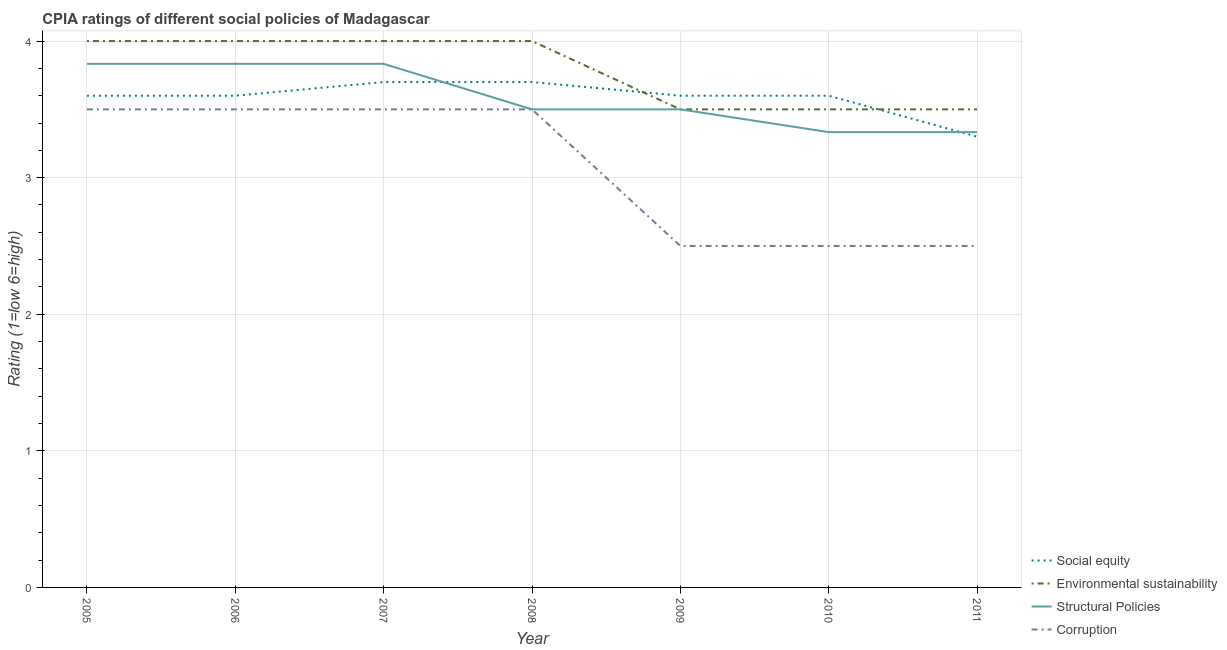How many different coloured lines are there?
Keep it short and to the point. 4. What is the cpia rating of environmental sustainability in 2008?
Ensure brevity in your answer.  4. In which year was the cpia rating of environmental sustainability maximum?
Your answer should be compact. 2005. What is the difference between the cpia rating of social equity in 2005 and that in 2006?
Give a very brief answer. 0. What is the difference between the cpia rating of social equity in 2005 and the cpia rating of corruption in 2008?
Your answer should be very brief. 0.1. What is the average cpia rating of social equity per year?
Provide a short and direct response. 3.59. In the year 2008, what is the difference between the cpia rating of environmental sustainability and cpia rating of social equity?
Offer a terse response. 0.3. In how many years, is the cpia rating of structural policies greater than 1.6?
Make the answer very short. 7. What is the ratio of the cpia rating of structural policies in 2006 to that in 2009?
Make the answer very short. 1.1. What is the difference between the highest and the lowest cpia rating of corruption?
Make the answer very short. 1. In how many years, is the cpia rating of social equity greater than the average cpia rating of social equity taken over all years?
Make the answer very short. 6. Is the sum of the cpia rating of structural policies in 2005 and 2011 greater than the maximum cpia rating of corruption across all years?
Your response must be concise. Yes. Is it the case that in every year, the sum of the cpia rating of corruption and cpia rating of environmental sustainability is greater than the sum of cpia rating of structural policies and cpia rating of social equity?
Make the answer very short. No. Is it the case that in every year, the sum of the cpia rating of social equity and cpia rating of environmental sustainability is greater than the cpia rating of structural policies?
Offer a very short reply. Yes. What is the difference between two consecutive major ticks on the Y-axis?
Your answer should be very brief. 1. How are the legend labels stacked?
Ensure brevity in your answer.  Vertical. What is the title of the graph?
Offer a very short reply. CPIA ratings of different social policies of Madagascar. What is the label or title of the X-axis?
Offer a very short reply. Year. What is the Rating (1=low 6=high) in Environmental sustainability in 2005?
Ensure brevity in your answer.  4. What is the Rating (1=low 6=high) of Structural Policies in 2005?
Offer a very short reply. 3.83. What is the Rating (1=low 6=high) of Corruption in 2005?
Provide a short and direct response. 3.5. What is the Rating (1=low 6=high) in Social equity in 2006?
Your answer should be very brief. 3.6. What is the Rating (1=low 6=high) in Environmental sustainability in 2006?
Provide a short and direct response. 4. What is the Rating (1=low 6=high) of Structural Policies in 2006?
Offer a terse response. 3.83. What is the Rating (1=low 6=high) of Corruption in 2006?
Give a very brief answer. 3.5. What is the Rating (1=low 6=high) of Social equity in 2007?
Your answer should be compact. 3.7. What is the Rating (1=low 6=high) of Environmental sustainability in 2007?
Your answer should be very brief. 4. What is the Rating (1=low 6=high) of Structural Policies in 2007?
Give a very brief answer. 3.83. What is the Rating (1=low 6=high) in Corruption in 2007?
Your answer should be very brief. 3.5. What is the Rating (1=low 6=high) of Social equity in 2008?
Provide a succinct answer. 3.7. What is the Rating (1=low 6=high) of Environmental sustainability in 2008?
Your answer should be compact. 4. What is the Rating (1=low 6=high) of Corruption in 2008?
Give a very brief answer. 3.5. What is the Rating (1=low 6=high) of Environmental sustainability in 2009?
Keep it short and to the point. 3.5. What is the Rating (1=low 6=high) in Structural Policies in 2010?
Ensure brevity in your answer.  3.33. What is the Rating (1=low 6=high) of Corruption in 2010?
Offer a terse response. 2.5. What is the Rating (1=low 6=high) in Structural Policies in 2011?
Give a very brief answer. 3.33. What is the Rating (1=low 6=high) in Corruption in 2011?
Your answer should be compact. 2.5. Across all years, what is the maximum Rating (1=low 6=high) in Social equity?
Ensure brevity in your answer.  3.7. Across all years, what is the maximum Rating (1=low 6=high) of Structural Policies?
Your answer should be compact. 3.83. Across all years, what is the maximum Rating (1=low 6=high) of Corruption?
Make the answer very short. 3.5. Across all years, what is the minimum Rating (1=low 6=high) of Social equity?
Offer a very short reply. 3.3. Across all years, what is the minimum Rating (1=low 6=high) in Environmental sustainability?
Keep it short and to the point. 3.5. Across all years, what is the minimum Rating (1=low 6=high) of Structural Policies?
Provide a short and direct response. 3.33. Across all years, what is the minimum Rating (1=low 6=high) of Corruption?
Give a very brief answer. 2.5. What is the total Rating (1=low 6=high) of Social equity in the graph?
Ensure brevity in your answer.  25.1. What is the total Rating (1=low 6=high) in Structural Policies in the graph?
Offer a very short reply. 25.17. What is the difference between the Rating (1=low 6=high) of Structural Policies in 2005 and that in 2006?
Provide a short and direct response. 0. What is the difference between the Rating (1=low 6=high) in Corruption in 2005 and that in 2006?
Offer a very short reply. 0. What is the difference between the Rating (1=low 6=high) of Social equity in 2005 and that in 2007?
Offer a terse response. -0.1. What is the difference between the Rating (1=low 6=high) of Corruption in 2005 and that in 2007?
Give a very brief answer. 0. What is the difference between the Rating (1=low 6=high) in Social equity in 2005 and that in 2008?
Give a very brief answer. -0.1. What is the difference between the Rating (1=low 6=high) in Environmental sustainability in 2005 and that in 2008?
Ensure brevity in your answer.  0. What is the difference between the Rating (1=low 6=high) of Structural Policies in 2005 and that in 2008?
Give a very brief answer. 0.33. What is the difference between the Rating (1=low 6=high) in Social equity in 2005 and that in 2009?
Your answer should be compact. 0. What is the difference between the Rating (1=low 6=high) of Structural Policies in 2005 and that in 2009?
Offer a terse response. 0.33. What is the difference between the Rating (1=low 6=high) of Social equity in 2005 and that in 2010?
Ensure brevity in your answer.  0. What is the difference between the Rating (1=low 6=high) of Environmental sustainability in 2005 and that in 2010?
Your answer should be compact. 0.5. What is the difference between the Rating (1=low 6=high) of Structural Policies in 2005 and that in 2010?
Offer a terse response. 0.5. What is the difference between the Rating (1=low 6=high) in Corruption in 2005 and that in 2010?
Your response must be concise. 1. What is the difference between the Rating (1=low 6=high) in Environmental sustainability in 2005 and that in 2011?
Your response must be concise. 0.5. What is the difference between the Rating (1=low 6=high) in Social equity in 2006 and that in 2007?
Your response must be concise. -0.1. What is the difference between the Rating (1=low 6=high) in Environmental sustainability in 2006 and that in 2007?
Your answer should be very brief. 0. What is the difference between the Rating (1=low 6=high) of Structural Policies in 2006 and that in 2007?
Keep it short and to the point. 0. What is the difference between the Rating (1=low 6=high) of Corruption in 2006 and that in 2007?
Provide a succinct answer. 0. What is the difference between the Rating (1=low 6=high) of Corruption in 2006 and that in 2008?
Ensure brevity in your answer.  0. What is the difference between the Rating (1=low 6=high) of Environmental sustainability in 2006 and that in 2009?
Make the answer very short. 0.5. What is the difference between the Rating (1=low 6=high) in Structural Policies in 2006 and that in 2009?
Give a very brief answer. 0.33. What is the difference between the Rating (1=low 6=high) of Social equity in 2006 and that in 2010?
Provide a succinct answer. 0. What is the difference between the Rating (1=low 6=high) in Social equity in 2006 and that in 2011?
Make the answer very short. 0.3. What is the difference between the Rating (1=low 6=high) in Environmental sustainability in 2006 and that in 2011?
Offer a terse response. 0.5. What is the difference between the Rating (1=low 6=high) in Corruption in 2006 and that in 2011?
Offer a terse response. 1. What is the difference between the Rating (1=low 6=high) of Social equity in 2007 and that in 2008?
Make the answer very short. 0. What is the difference between the Rating (1=low 6=high) in Corruption in 2007 and that in 2008?
Offer a very short reply. 0. What is the difference between the Rating (1=low 6=high) in Environmental sustainability in 2007 and that in 2010?
Offer a very short reply. 0.5. What is the difference between the Rating (1=low 6=high) in Social equity in 2007 and that in 2011?
Make the answer very short. 0.4. What is the difference between the Rating (1=low 6=high) in Structural Policies in 2008 and that in 2009?
Ensure brevity in your answer.  0. What is the difference between the Rating (1=low 6=high) in Environmental sustainability in 2008 and that in 2010?
Ensure brevity in your answer.  0.5. What is the difference between the Rating (1=low 6=high) of Corruption in 2008 and that in 2010?
Offer a terse response. 1. What is the difference between the Rating (1=low 6=high) of Structural Policies in 2008 and that in 2011?
Make the answer very short. 0.17. What is the difference between the Rating (1=low 6=high) in Corruption in 2008 and that in 2011?
Give a very brief answer. 1. What is the difference between the Rating (1=low 6=high) in Social equity in 2009 and that in 2010?
Give a very brief answer. 0. What is the difference between the Rating (1=low 6=high) in Environmental sustainability in 2009 and that in 2010?
Provide a succinct answer. 0. What is the difference between the Rating (1=low 6=high) in Structural Policies in 2009 and that in 2010?
Provide a short and direct response. 0.17. What is the difference between the Rating (1=low 6=high) of Corruption in 2009 and that in 2010?
Ensure brevity in your answer.  0. What is the difference between the Rating (1=low 6=high) in Social equity in 2009 and that in 2011?
Make the answer very short. 0.3. What is the difference between the Rating (1=low 6=high) in Structural Policies in 2010 and that in 2011?
Your response must be concise. 0. What is the difference between the Rating (1=low 6=high) in Social equity in 2005 and the Rating (1=low 6=high) in Environmental sustainability in 2006?
Offer a very short reply. -0.4. What is the difference between the Rating (1=low 6=high) in Social equity in 2005 and the Rating (1=low 6=high) in Structural Policies in 2006?
Keep it short and to the point. -0.23. What is the difference between the Rating (1=low 6=high) in Environmental sustainability in 2005 and the Rating (1=low 6=high) in Structural Policies in 2006?
Offer a very short reply. 0.17. What is the difference between the Rating (1=low 6=high) in Structural Policies in 2005 and the Rating (1=low 6=high) in Corruption in 2006?
Offer a very short reply. 0.33. What is the difference between the Rating (1=low 6=high) in Social equity in 2005 and the Rating (1=low 6=high) in Environmental sustainability in 2007?
Provide a succinct answer. -0.4. What is the difference between the Rating (1=low 6=high) in Social equity in 2005 and the Rating (1=low 6=high) in Structural Policies in 2007?
Give a very brief answer. -0.23. What is the difference between the Rating (1=low 6=high) of Social equity in 2005 and the Rating (1=low 6=high) of Corruption in 2007?
Ensure brevity in your answer.  0.1. What is the difference between the Rating (1=low 6=high) in Environmental sustainability in 2005 and the Rating (1=low 6=high) in Corruption in 2007?
Ensure brevity in your answer.  0.5. What is the difference between the Rating (1=low 6=high) of Social equity in 2005 and the Rating (1=low 6=high) of Environmental sustainability in 2008?
Keep it short and to the point. -0.4. What is the difference between the Rating (1=low 6=high) of Social equity in 2005 and the Rating (1=low 6=high) of Corruption in 2008?
Your response must be concise. 0.1. What is the difference between the Rating (1=low 6=high) in Environmental sustainability in 2005 and the Rating (1=low 6=high) in Corruption in 2008?
Your answer should be very brief. 0.5. What is the difference between the Rating (1=low 6=high) of Structural Policies in 2005 and the Rating (1=low 6=high) of Corruption in 2008?
Your answer should be very brief. 0.33. What is the difference between the Rating (1=low 6=high) in Social equity in 2005 and the Rating (1=low 6=high) in Environmental sustainability in 2009?
Provide a short and direct response. 0.1. What is the difference between the Rating (1=low 6=high) in Social equity in 2005 and the Rating (1=low 6=high) in Corruption in 2009?
Provide a short and direct response. 1.1. What is the difference between the Rating (1=low 6=high) of Environmental sustainability in 2005 and the Rating (1=low 6=high) of Structural Policies in 2009?
Provide a succinct answer. 0.5. What is the difference between the Rating (1=low 6=high) of Environmental sustainability in 2005 and the Rating (1=low 6=high) of Corruption in 2009?
Your response must be concise. 1.5. What is the difference between the Rating (1=low 6=high) in Structural Policies in 2005 and the Rating (1=low 6=high) in Corruption in 2009?
Your response must be concise. 1.33. What is the difference between the Rating (1=low 6=high) of Social equity in 2005 and the Rating (1=low 6=high) of Environmental sustainability in 2010?
Provide a short and direct response. 0.1. What is the difference between the Rating (1=low 6=high) in Social equity in 2005 and the Rating (1=low 6=high) in Structural Policies in 2010?
Your answer should be very brief. 0.27. What is the difference between the Rating (1=low 6=high) in Social equity in 2005 and the Rating (1=low 6=high) in Corruption in 2010?
Provide a succinct answer. 1.1. What is the difference between the Rating (1=low 6=high) in Environmental sustainability in 2005 and the Rating (1=low 6=high) in Structural Policies in 2010?
Your answer should be compact. 0.67. What is the difference between the Rating (1=low 6=high) in Environmental sustainability in 2005 and the Rating (1=low 6=high) in Corruption in 2010?
Keep it short and to the point. 1.5. What is the difference between the Rating (1=low 6=high) of Social equity in 2005 and the Rating (1=low 6=high) of Structural Policies in 2011?
Offer a very short reply. 0.27. What is the difference between the Rating (1=low 6=high) of Environmental sustainability in 2005 and the Rating (1=low 6=high) of Corruption in 2011?
Keep it short and to the point. 1.5. What is the difference between the Rating (1=low 6=high) of Structural Policies in 2005 and the Rating (1=low 6=high) of Corruption in 2011?
Offer a terse response. 1.33. What is the difference between the Rating (1=low 6=high) in Social equity in 2006 and the Rating (1=low 6=high) in Structural Policies in 2007?
Give a very brief answer. -0.23. What is the difference between the Rating (1=low 6=high) of Social equity in 2006 and the Rating (1=low 6=high) of Corruption in 2007?
Ensure brevity in your answer.  0.1. What is the difference between the Rating (1=low 6=high) in Environmental sustainability in 2006 and the Rating (1=low 6=high) in Corruption in 2007?
Offer a terse response. 0.5. What is the difference between the Rating (1=low 6=high) in Social equity in 2006 and the Rating (1=low 6=high) in Environmental sustainability in 2008?
Provide a succinct answer. -0.4. What is the difference between the Rating (1=low 6=high) of Social equity in 2006 and the Rating (1=low 6=high) of Structural Policies in 2008?
Offer a terse response. 0.1. What is the difference between the Rating (1=low 6=high) in Social equity in 2006 and the Rating (1=low 6=high) in Corruption in 2008?
Offer a very short reply. 0.1. What is the difference between the Rating (1=low 6=high) of Environmental sustainability in 2006 and the Rating (1=low 6=high) of Structural Policies in 2008?
Provide a succinct answer. 0.5. What is the difference between the Rating (1=low 6=high) in Structural Policies in 2006 and the Rating (1=low 6=high) in Corruption in 2008?
Offer a very short reply. 0.33. What is the difference between the Rating (1=low 6=high) of Social equity in 2006 and the Rating (1=low 6=high) of Environmental sustainability in 2009?
Provide a short and direct response. 0.1. What is the difference between the Rating (1=low 6=high) of Social equity in 2006 and the Rating (1=low 6=high) of Structural Policies in 2009?
Provide a succinct answer. 0.1. What is the difference between the Rating (1=low 6=high) of Social equity in 2006 and the Rating (1=low 6=high) of Corruption in 2009?
Offer a very short reply. 1.1. What is the difference between the Rating (1=low 6=high) in Environmental sustainability in 2006 and the Rating (1=low 6=high) in Structural Policies in 2009?
Provide a short and direct response. 0.5. What is the difference between the Rating (1=low 6=high) in Environmental sustainability in 2006 and the Rating (1=low 6=high) in Corruption in 2009?
Your response must be concise. 1.5. What is the difference between the Rating (1=low 6=high) of Social equity in 2006 and the Rating (1=low 6=high) of Environmental sustainability in 2010?
Provide a short and direct response. 0.1. What is the difference between the Rating (1=low 6=high) of Social equity in 2006 and the Rating (1=low 6=high) of Structural Policies in 2010?
Offer a terse response. 0.27. What is the difference between the Rating (1=low 6=high) in Social equity in 2006 and the Rating (1=low 6=high) in Corruption in 2010?
Give a very brief answer. 1.1. What is the difference between the Rating (1=low 6=high) in Environmental sustainability in 2006 and the Rating (1=low 6=high) in Structural Policies in 2010?
Ensure brevity in your answer.  0.67. What is the difference between the Rating (1=low 6=high) in Environmental sustainability in 2006 and the Rating (1=low 6=high) in Corruption in 2010?
Offer a terse response. 1.5. What is the difference between the Rating (1=low 6=high) of Structural Policies in 2006 and the Rating (1=low 6=high) of Corruption in 2010?
Offer a very short reply. 1.33. What is the difference between the Rating (1=low 6=high) in Social equity in 2006 and the Rating (1=low 6=high) in Environmental sustainability in 2011?
Make the answer very short. 0.1. What is the difference between the Rating (1=low 6=high) of Social equity in 2006 and the Rating (1=low 6=high) of Structural Policies in 2011?
Your answer should be very brief. 0.27. What is the difference between the Rating (1=low 6=high) of Social equity in 2006 and the Rating (1=low 6=high) of Corruption in 2011?
Your answer should be very brief. 1.1. What is the difference between the Rating (1=low 6=high) of Structural Policies in 2006 and the Rating (1=low 6=high) of Corruption in 2011?
Ensure brevity in your answer.  1.33. What is the difference between the Rating (1=low 6=high) in Social equity in 2007 and the Rating (1=low 6=high) in Corruption in 2008?
Your response must be concise. 0.2. What is the difference between the Rating (1=low 6=high) in Environmental sustainability in 2007 and the Rating (1=low 6=high) in Structural Policies in 2008?
Your response must be concise. 0.5. What is the difference between the Rating (1=low 6=high) in Social equity in 2007 and the Rating (1=low 6=high) in Corruption in 2009?
Your answer should be very brief. 1.2. What is the difference between the Rating (1=low 6=high) in Environmental sustainability in 2007 and the Rating (1=low 6=high) in Structural Policies in 2009?
Your answer should be compact. 0.5. What is the difference between the Rating (1=low 6=high) of Structural Policies in 2007 and the Rating (1=low 6=high) of Corruption in 2009?
Ensure brevity in your answer.  1.33. What is the difference between the Rating (1=low 6=high) of Social equity in 2007 and the Rating (1=low 6=high) of Environmental sustainability in 2010?
Offer a terse response. 0.2. What is the difference between the Rating (1=low 6=high) in Social equity in 2007 and the Rating (1=low 6=high) in Structural Policies in 2010?
Make the answer very short. 0.37. What is the difference between the Rating (1=low 6=high) in Social equity in 2007 and the Rating (1=low 6=high) in Structural Policies in 2011?
Offer a terse response. 0.37. What is the difference between the Rating (1=low 6=high) of Environmental sustainability in 2007 and the Rating (1=low 6=high) of Corruption in 2011?
Provide a succinct answer. 1.5. What is the difference between the Rating (1=low 6=high) in Social equity in 2008 and the Rating (1=low 6=high) in Environmental sustainability in 2009?
Offer a terse response. 0.2. What is the difference between the Rating (1=low 6=high) in Social equity in 2008 and the Rating (1=low 6=high) in Structural Policies in 2009?
Ensure brevity in your answer.  0.2. What is the difference between the Rating (1=low 6=high) in Environmental sustainability in 2008 and the Rating (1=low 6=high) in Corruption in 2009?
Offer a very short reply. 1.5. What is the difference between the Rating (1=low 6=high) in Structural Policies in 2008 and the Rating (1=low 6=high) in Corruption in 2009?
Your response must be concise. 1. What is the difference between the Rating (1=low 6=high) in Social equity in 2008 and the Rating (1=low 6=high) in Structural Policies in 2010?
Provide a succinct answer. 0.37. What is the difference between the Rating (1=low 6=high) of Environmental sustainability in 2008 and the Rating (1=low 6=high) of Structural Policies in 2010?
Offer a very short reply. 0.67. What is the difference between the Rating (1=low 6=high) in Structural Policies in 2008 and the Rating (1=low 6=high) in Corruption in 2010?
Provide a short and direct response. 1. What is the difference between the Rating (1=low 6=high) in Social equity in 2008 and the Rating (1=low 6=high) in Environmental sustainability in 2011?
Your answer should be very brief. 0.2. What is the difference between the Rating (1=low 6=high) in Social equity in 2008 and the Rating (1=low 6=high) in Structural Policies in 2011?
Your answer should be compact. 0.37. What is the difference between the Rating (1=low 6=high) of Environmental sustainability in 2008 and the Rating (1=low 6=high) of Structural Policies in 2011?
Your answer should be compact. 0.67. What is the difference between the Rating (1=low 6=high) in Structural Policies in 2008 and the Rating (1=low 6=high) in Corruption in 2011?
Your answer should be compact. 1. What is the difference between the Rating (1=low 6=high) in Social equity in 2009 and the Rating (1=low 6=high) in Structural Policies in 2010?
Your answer should be compact. 0.27. What is the difference between the Rating (1=low 6=high) in Social equity in 2009 and the Rating (1=low 6=high) in Corruption in 2010?
Give a very brief answer. 1.1. What is the difference between the Rating (1=low 6=high) in Environmental sustainability in 2009 and the Rating (1=low 6=high) in Structural Policies in 2010?
Offer a terse response. 0.17. What is the difference between the Rating (1=low 6=high) in Social equity in 2009 and the Rating (1=low 6=high) in Structural Policies in 2011?
Your response must be concise. 0.27. What is the difference between the Rating (1=low 6=high) of Social equity in 2009 and the Rating (1=low 6=high) of Corruption in 2011?
Offer a very short reply. 1.1. What is the difference between the Rating (1=low 6=high) in Structural Policies in 2009 and the Rating (1=low 6=high) in Corruption in 2011?
Provide a succinct answer. 1. What is the difference between the Rating (1=low 6=high) of Social equity in 2010 and the Rating (1=low 6=high) of Environmental sustainability in 2011?
Your response must be concise. 0.1. What is the difference between the Rating (1=low 6=high) in Social equity in 2010 and the Rating (1=low 6=high) in Structural Policies in 2011?
Provide a short and direct response. 0.27. What is the difference between the Rating (1=low 6=high) of Environmental sustainability in 2010 and the Rating (1=low 6=high) of Structural Policies in 2011?
Provide a succinct answer. 0.17. What is the difference between the Rating (1=low 6=high) of Structural Policies in 2010 and the Rating (1=low 6=high) of Corruption in 2011?
Make the answer very short. 0.83. What is the average Rating (1=low 6=high) of Social equity per year?
Make the answer very short. 3.59. What is the average Rating (1=low 6=high) in Environmental sustainability per year?
Give a very brief answer. 3.79. What is the average Rating (1=low 6=high) in Structural Policies per year?
Provide a succinct answer. 3.6. What is the average Rating (1=low 6=high) of Corruption per year?
Offer a terse response. 3.07. In the year 2005, what is the difference between the Rating (1=low 6=high) of Social equity and Rating (1=low 6=high) of Environmental sustainability?
Offer a very short reply. -0.4. In the year 2005, what is the difference between the Rating (1=low 6=high) in Social equity and Rating (1=low 6=high) in Structural Policies?
Make the answer very short. -0.23. In the year 2005, what is the difference between the Rating (1=low 6=high) in Social equity and Rating (1=low 6=high) in Corruption?
Your answer should be compact. 0.1. In the year 2005, what is the difference between the Rating (1=low 6=high) in Environmental sustainability and Rating (1=low 6=high) in Structural Policies?
Provide a succinct answer. 0.17. In the year 2005, what is the difference between the Rating (1=low 6=high) of Environmental sustainability and Rating (1=low 6=high) of Corruption?
Your answer should be very brief. 0.5. In the year 2005, what is the difference between the Rating (1=low 6=high) of Structural Policies and Rating (1=low 6=high) of Corruption?
Provide a succinct answer. 0.33. In the year 2006, what is the difference between the Rating (1=low 6=high) in Social equity and Rating (1=low 6=high) in Structural Policies?
Keep it short and to the point. -0.23. In the year 2006, what is the difference between the Rating (1=low 6=high) in Environmental sustainability and Rating (1=low 6=high) in Structural Policies?
Ensure brevity in your answer.  0.17. In the year 2007, what is the difference between the Rating (1=low 6=high) in Social equity and Rating (1=low 6=high) in Environmental sustainability?
Provide a succinct answer. -0.3. In the year 2007, what is the difference between the Rating (1=low 6=high) of Social equity and Rating (1=low 6=high) of Structural Policies?
Provide a short and direct response. -0.13. In the year 2007, what is the difference between the Rating (1=low 6=high) of Structural Policies and Rating (1=low 6=high) of Corruption?
Make the answer very short. 0.33. In the year 2008, what is the difference between the Rating (1=low 6=high) of Environmental sustainability and Rating (1=low 6=high) of Structural Policies?
Offer a very short reply. 0.5. In the year 2009, what is the difference between the Rating (1=low 6=high) of Social equity and Rating (1=low 6=high) of Corruption?
Offer a very short reply. 1.1. In the year 2009, what is the difference between the Rating (1=low 6=high) of Environmental sustainability and Rating (1=low 6=high) of Structural Policies?
Provide a short and direct response. 0. In the year 2009, what is the difference between the Rating (1=low 6=high) of Environmental sustainability and Rating (1=low 6=high) of Corruption?
Provide a succinct answer. 1. In the year 2010, what is the difference between the Rating (1=low 6=high) of Social equity and Rating (1=low 6=high) of Environmental sustainability?
Your response must be concise. 0.1. In the year 2010, what is the difference between the Rating (1=low 6=high) in Social equity and Rating (1=low 6=high) in Structural Policies?
Your answer should be very brief. 0.27. In the year 2010, what is the difference between the Rating (1=low 6=high) in Social equity and Rating (1=low 6=high) in Corruption?
Provide a succinct answer. 1.1. In the year 2010, what is the difference between the Rating (1=low 6=high) of Environmental sustainability and Rating (1=low 6=high) of Corruption?
Offer a very short reply. 1. In the year 2011, what is the difference between the Rating (1=low 6=high) in Social equity and Rating (1=low 6=high) in Structural Policies?
Keep it short and to the point. -0.03. In the year 2011, what is the difference between the Rating (1=low 6=high) in Social equity and Rating (1=low 6=high) in Corruption?
Offer a very short reply. 0.8. In the year 2011, what is the difference between the Rating (1=low 6=high) in Structural Policies and Rating (1=low 6=high) in Corruption?
Your answer should be compact. 0.83. What is the ratio of the Rating (1=low 6=high) of Environmental sustainability in 2005 to that in 2006?
Your answer should be very brief. 1. What is the ratio of the Rating (1=low 6=high) of Social equity in 2005 to that in 2007?
Your answer should be very brief. 0.97. What is the ratio of the Rating (1=low 6=high) of Environmental sustainability in 2005 to that in 2007?
Make the answer very short. 1. What is the ratio of the Rating (1=low 6=high) of Structural Policies in 2005 to that in 2007?
Ensure brevity in your answer.  1. What is the ratio of the Rating (1=low 6=high) in Environmental sustainability in 2005 to that in 2008?
Offer a terse response. 1. What is the ratio of the Rating (1=low 6=high) in Structural Policies in 2005 to that in 2008?
Give a very brief answer. 1.1. What is the ratio of the Rating (1=low 6=high) of Social equity in 2005 to that in 2009?
Offer a very short reply. 1. What is the ratio of the Rating (1=low 6=high) in Structural Policies in 2005 to that in 2009?
Provide a succinct answer. 1.1. What is the ratio of the Rating (1=low 6=high) in Corruption in 2005 to that in 2009?
Ensure brevity in your answer.  1.4. What is the ratio of the Rating (1=low 6=high) in Environmental sustainability in 2005 to that in 2010?
Keep it short and to the point. 1.14. What is the ratio of the Rating (1=low 6=high) of Structural Policies in 2005 to that in 2010?
Offer a terse response. 1.15. What is the ratio of the Rating (1=low 6=high) in Social equity in 2005 to that in 2011?
Provide a succinct answer. 1.09. What is the ratio of the Rating (1=low 6=high) of Environmental sustainability in 2005 to that in 2011?
Offer a terse response. 1.14. What is the ratio of the Rating (1=low 6=high) of Structural Policies in 2005 to that in 2011?
Your answer should be compact. 1.15. What is the ratio of the Rating (1=low 6=high) in Social equity in 2006 to that in 2007?
Make the answer very short. 0.97. What is the ratio of the Rating (1=low 6=high) in Environmental sustainability in 2006 to that in 2007?
Offer a terse response. 1. What is the ratio of the Rating (1=low 6=high) in Structural Policies in 2006 to that in 2007?
Your response must be concise. 1. What is the ratio of the Rating (1=low 6=high) in Environmental sustainability in 2006 to that in 2008?
Ensure brevity in your answer.  1. What is the ratio of the Rating (1=low 6=high) of Structural Policies in 2006 to that in 2008?
Offer a terse response. 1.1. What is the ratio of the Rating (1=low 6=high) of Corruption in 2006 to that in 2008?
Give a very brief answer. 1. What is the ratio of the Rating (1=low 6=high) of Social equity in 2006 to that in 2009?
Ensure brevity in your answer.  1. What is the ratio of the Rating (1=low 6=high) of Environmental sustainability in 2006 to that in 2009?
Give a very brief answer. 1.14. What is the ratio of the Rating (1=low 6=high) in Structural Policies in 2006 to that in 2009?
Give a very brief answer. 1.1. What is the ratio of the Rating (1=low 6=high) in Social equity in 2006 to that in 2010?
Give a very brief answer. 1. What is the ratio of the Rating (1=low 6=high) of Structural Policies in 2006 to that in 2010?
Provide a short and direct response. 1.15. What is the ratio of the Rating (1=low 6=high) of Structural Policies in 2006 to that in 2011?
Make the answer very short. 1.15. What is the ratio of the Rating (1=low 6=high) in Corruption in 2006 to that in 2011?
Make the answer very short. 1.4. What is the ratio of the Rating (1=low 6=high) in Structural Policies in 2007 to that in 2008?
Your answer should be compact. 1.1. What is the ratio of the Rating (1=low 6=high) in Social equity in 2007 to that in 2009?
Your response must be concise. 1.03. What is the ratio of the Rating (1=low 6=high) of Structural Policies in 2007 to that in 2009?
Your answer should be very brief. 1.1. What is the ratio of the Rating (1=low 6=high) in Corruption in 2007 to that in 2009?
Keep it short and to the point. 1.4. What is the ratio of the Rating (1=low 6=high) in Social equity in 2007 to that in 2010?
Your response must be concise. 1.03. What is the ratio of the Rating (1=low 6=high) in Environmental sustainability in 2007 to that in 2010?
Offer a terse response. 1.14. What is the ratio of the Rating (1=low 6=high) in Structural Policies in 2007 to that in 2010?
Your response must be concise. 1.15. What is the ratio of the Rating (1=low 6=high) in Social equity in 2007 to that in 2011?
Make the answer very short. 1.12. What is the ratio of the Rating (1=low 6=high) in Environmental sustainability in 2007 to that in 2011?
Make the answer very short. 1.14. What is the ratio of the Rating (1=low 6=high) of Structural Policies in 2007 to that in 2011?
Offer a very short reply. 1.15. What is the ratio of the Rating (1=low 6=high) of Social equity in 2008 to that in 2009?
Provide a short and direct response. 1.03. What is the ratio of the Rating (1=low 6=high) in Structural Policies in 2008 to that in 2009?
Your response must be concise. 1. What is the ratio of the Rating (1=low 6=high) in Social equity in 2008 to that in 2010?
Your answer should be compact. 1.03. What is the ratio of the Rating (1=low 6=high) in Environmental sustainability in 2008 to that in 2010?
Offer a terse response. 1.14. What is the ratio of the Rating (1=low 6=high) in Social equity in 2008 to that in 2011?
Your answer should be compact. 1.12. What is the ratio of the Rating (1=low 6=high) in Structural Policies in 2009 to that in 2010?
Make the answer very short. 1.05. What is the ratio of the Rating (1=low 6=high) of Social equity in 2009 to that in 2011?
Make the answer very short. 1.09. What is the ratio of the Rating (1=low 6=high) of Social equity in 2010 to that in 2011?
Your answer should be very brief. 1.09. What is the ratio of the Rating (1=low 6=high) of Structural Policies in 2010 to that in 2011?
Make the answer very short. 1. What is the ratio of the Rating (1=low 6=high) of Corruption in 2010 to that in 2011?
Your answer should be very brief. 1. What is the difference between the highest and the second highest Rating (1=low 6=high) in Social equity?
Provide a short and direct response. 0. What is the difference between the highest and the second highest Rating (1=low 6=high) of Environmental sustainability?
Your response must be concise. 0. What is the difference between the highest and the second highest Rating (1=low 6=high) of Structural Policies?
Your answer should be compact. 0. What is the difference between the highest and the lowest Rating (1=low 6=high) of Environmental sustainability?
Your response must be concise. 0.5. 